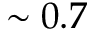<formula> <loc_0><loc_0><loc_500><loc_500>\sim 0 . 7</formula> 